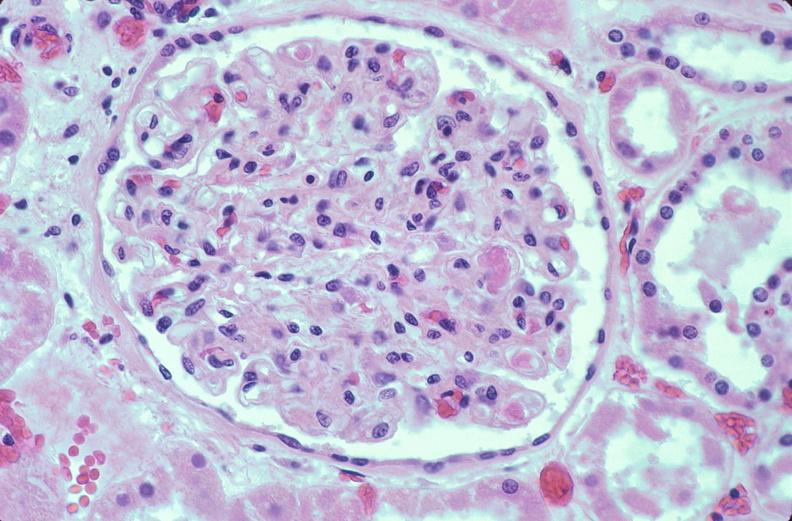how is kidney , microthrombi , disseminated coagulation?
Answer the question using a single word or phrase. Intravascular 